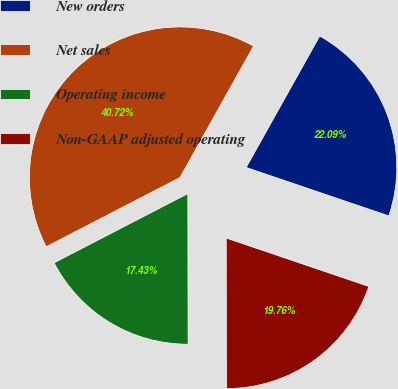<chart> <loc_0><loc_0><loc_500><loc_500><pie_chart><fcel>New orders<fcel>Net sales<fcel>Operating income<fcel>Non-GAAP adjusted operating<nl><fcel>22.09%<fcel>40.72%<fcel>17.43%<fcel>19.76%<nl></chart> 